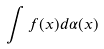<formula> <loc_0><loc_0><loc_500><loc_500>\int f ( x ) d \alpha ( x )</formula> 